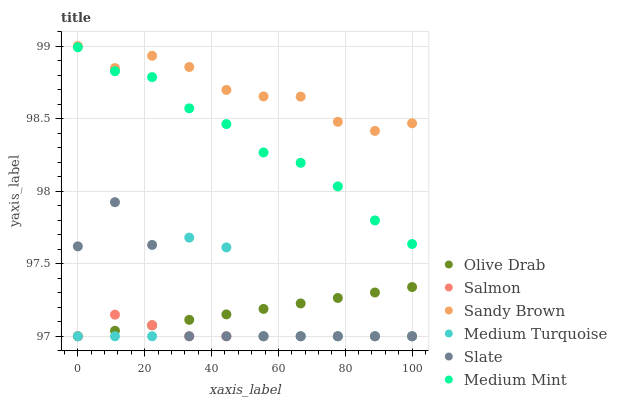Does Salmon have the minimum area under the curve?
Answer yes or no. Yes. Does Sandy Brown have the maximum area under the curve?
Answer yes or no. Yes. Does Slate have the minimum area under the curve?
Answer yes or no. No. Does Slate have the maximum area under the curve?
Answer yes or no. No. Is Olive Drab the smoothest?
Answer yes or no. Yes. Is Medium Turquoise the roughest?
Answer yes or no. Yes. Is Slate the smoothest?
Answer yes or no. No. Is Slate the roughest?
Answer yes or no. No. Does Slate have the lowest value?
Answer yes or no. Yes. Does Sandy Brown have the lowest value?
Answer yes or no. No. Does Sandy Brown have the highest value?
Answer yes or no. Yes. Does Slate have the highest value?
Answer yes or no. No. Is Slate less than Medium Mint?
Answer yes or no. Yes. Is Medium Mint greater than Olive Drab?
Answer yes or no. Yes. Does Olive Drab intersect Salmon?
Answer yes or no. Yes. Is Olive Drab less than Salmon?
Answer yes or no. No. Is Olive Drab greater than Salmon?
Answer yes or no. No. Does Slate intersect Medium Mint?
Answer yes or no. No. 